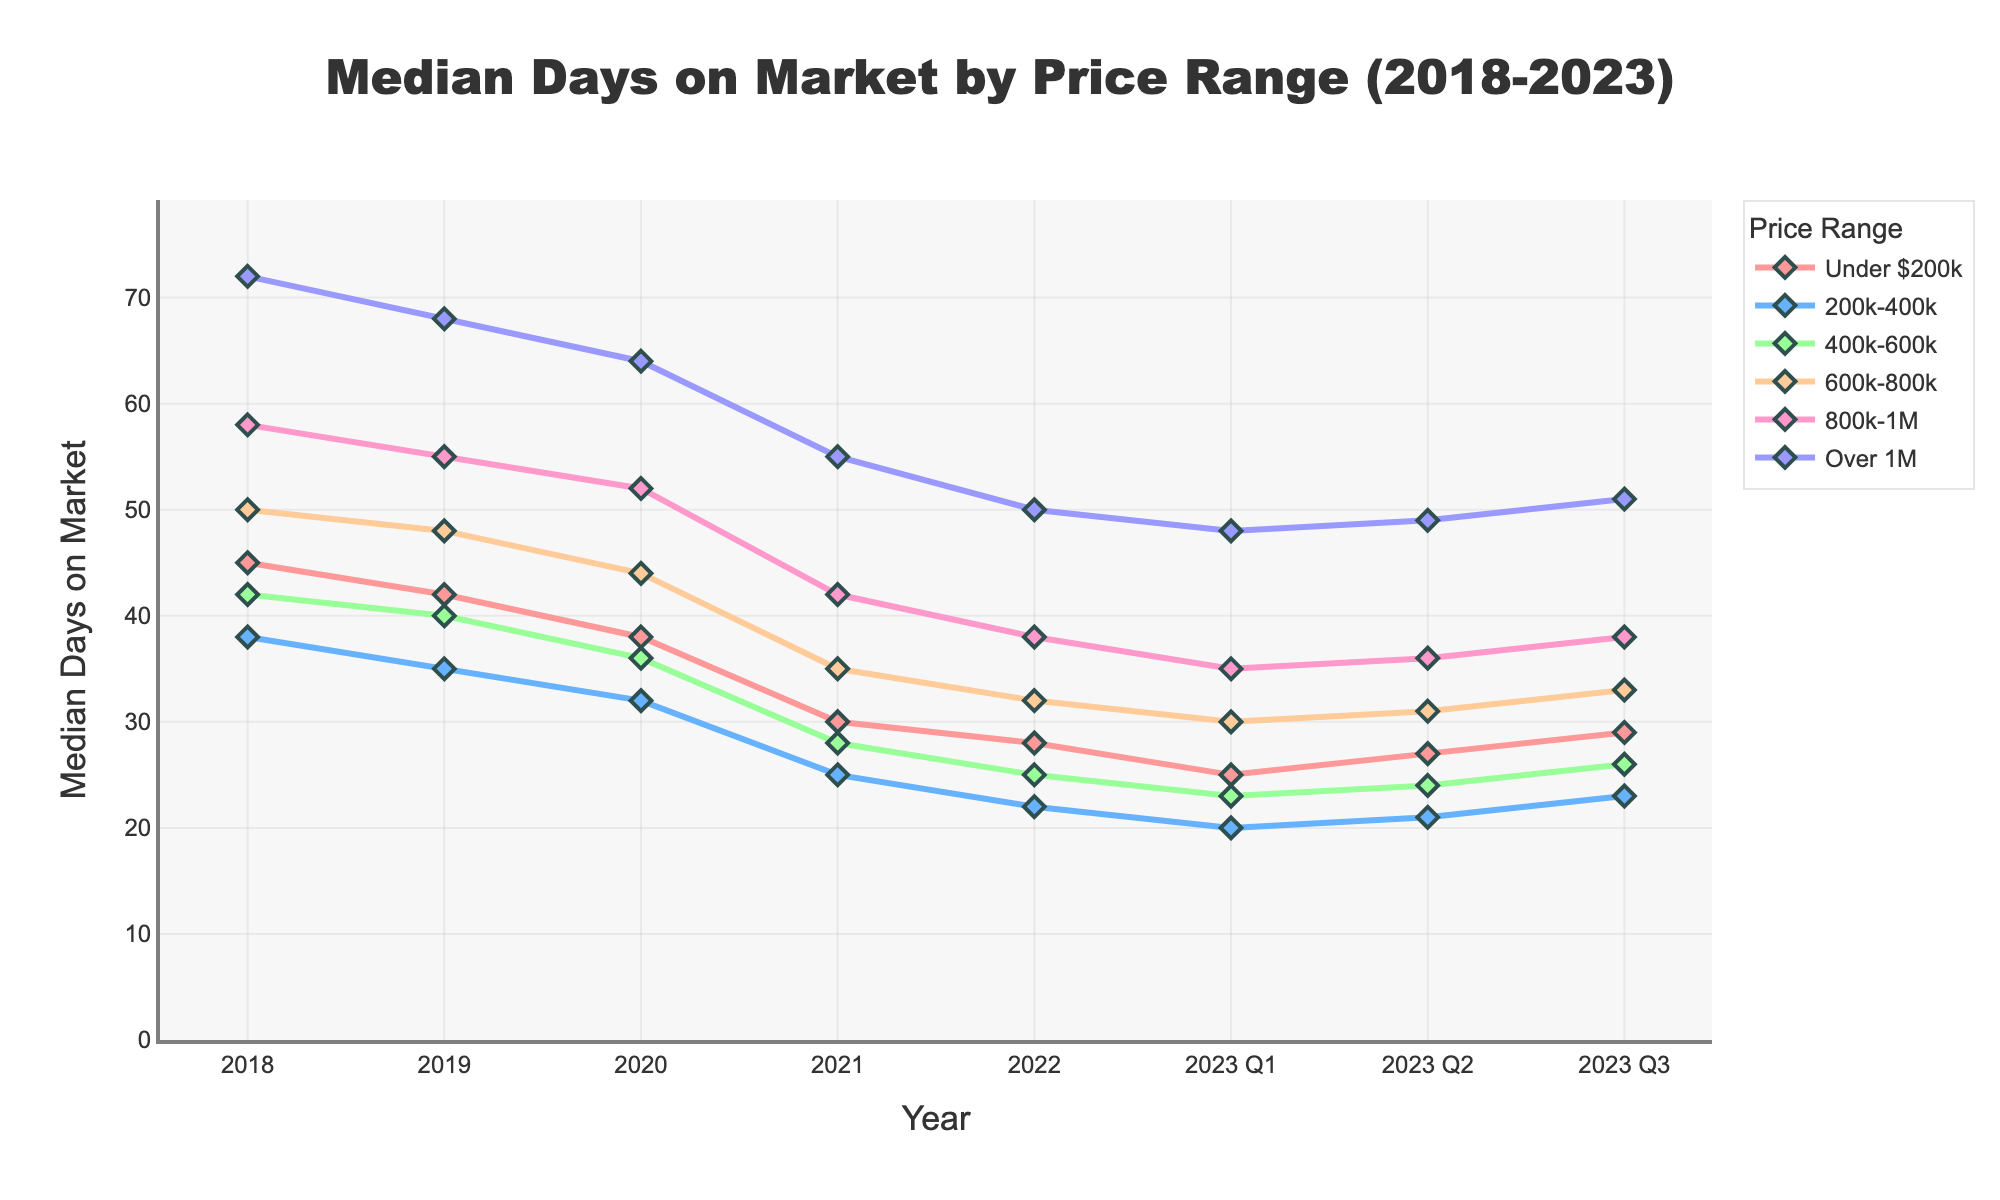What's the general trend for median days on market for all price ranges from 2018 to 2023? To identify the general trend, observe the overall direction of the lines for each price range from 2018 to 2023. Nearly all lines show a consistent downward trend over the years, indicating that the median days on market have generally decreased for all price ranges.
Answer: Decreasing How does the median days on market in Q2 2023 for properties priced under $200k compare to those priced over $1M? Look at the median days on market in Q2 2023 for both price ranges on the figure. For properties under $200k, it is 27 days. For properties over $1M, it is 49 days.
Answer: 27 days vs. 49 days What is the difference in median days on market between properties priced $200k-$400k and $800k-$1M in 2021? In 2021, properties priced $200k-$400k have a median of 25 days on market, while those priced $800k-$1M have 42 days. Subtract the two values: 42 - 25 = 17.
Answer: 17 days Which price range experienced the largest decrease in median days on market from 2018 to 2021? Calculate the decrease for each price range by subtracting the median days on market in 2021 from that in 2018. The largest decrease occurred in the $800k-$1M range, dropping from 58 to 42 days.
Answer: $800k-$1M In 2020, compare the median days on market for properties priced $400k-$600k with properties priced under $200k. Which is lower? In 2020, properties priced $400k-$600k had 36 days on market, while those under $200k had 38 days. Therefore, $400k-$600k is lower.
Answer: $400k-$600k What is the average median days on market for properties priced $600k-$800k across all the years shown? Sum the median days on market for $600k-$800k over all years and divide by the number of years (6 years and 3 quarters ≈ 6.75 years). (50+48+44+35+32+(30+31+33)/3) / 6.75 ≈ 39.2 days.
Answer: 39.2 days Comparing 2018 and 2023 Q3, which price range saw the smallest change in median days on market? Calculate the change for each price range by finding the difference between 2023 Q3 and 2018. The smallest change is seen in the 'Under $200k' range, which decreased from 45 to 29 days, a change of 16 days.
Answer: Under $200k Between 2022 and Q1 2023, which price range had the largest percentage decrease in median days on market? Calculate the percentage decrease for each price range by [(Value in 2022 - Value in Q1 2023) / Value in 2022] * 100. The largest percentage decrease is in the $400k-$600k range, from 25 to 23 days, which is a decrease of (2/25) * 100 = 8%.
Answer: $400k-$600k How did the median days on market for the $200k-$400k range change from Q1 2023 to Q3 2023? In Q1 2023, the median days for $200k-$400k were 20. In Q3 2023, it was 23, indicating an increase.
Answer: Increase 